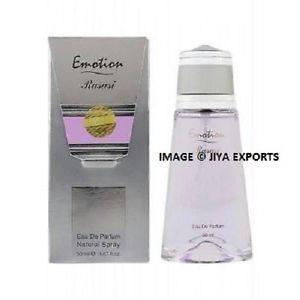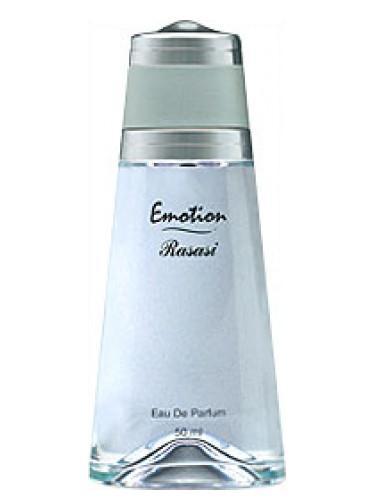The first image is the image on the left, the second image is the image on the right. Assess this claim about the two images: "There is a bottle of perfume without a box next to it.". Correct or not? Answer yes or no. Yes. 